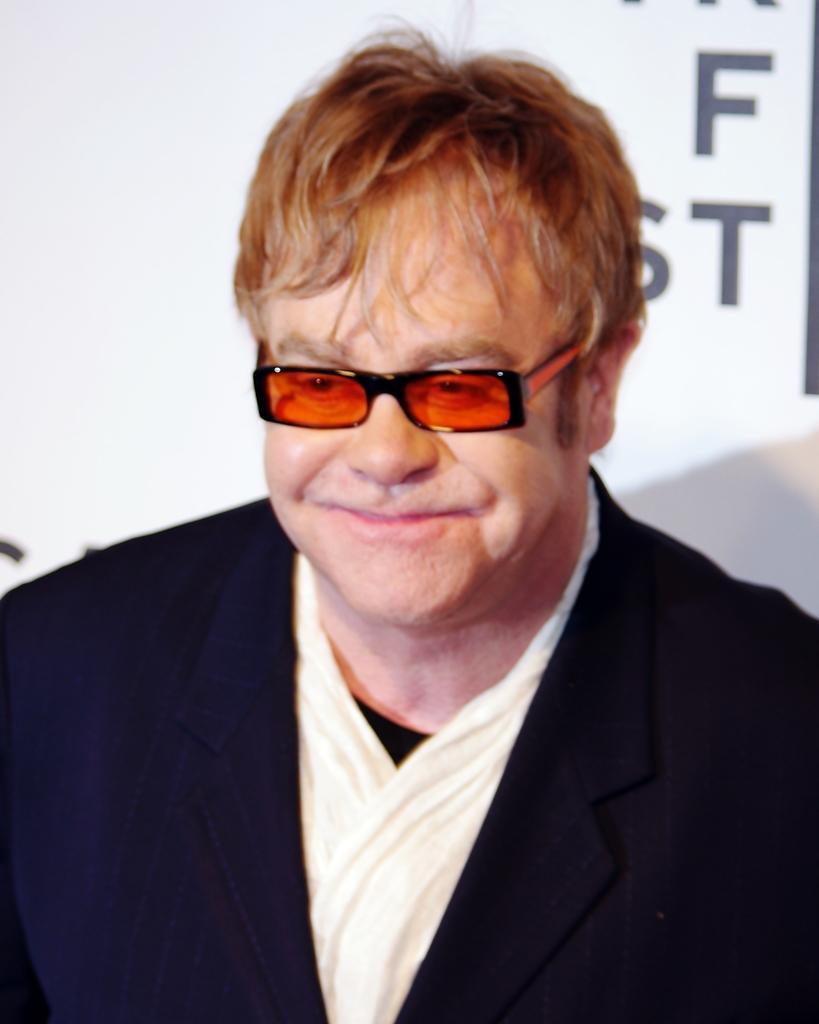Describe this image in one or two sentences. In the image there is a man with orange color goggles, black jacket and white shirt. He is smiling. Behind him there is a white poster. 